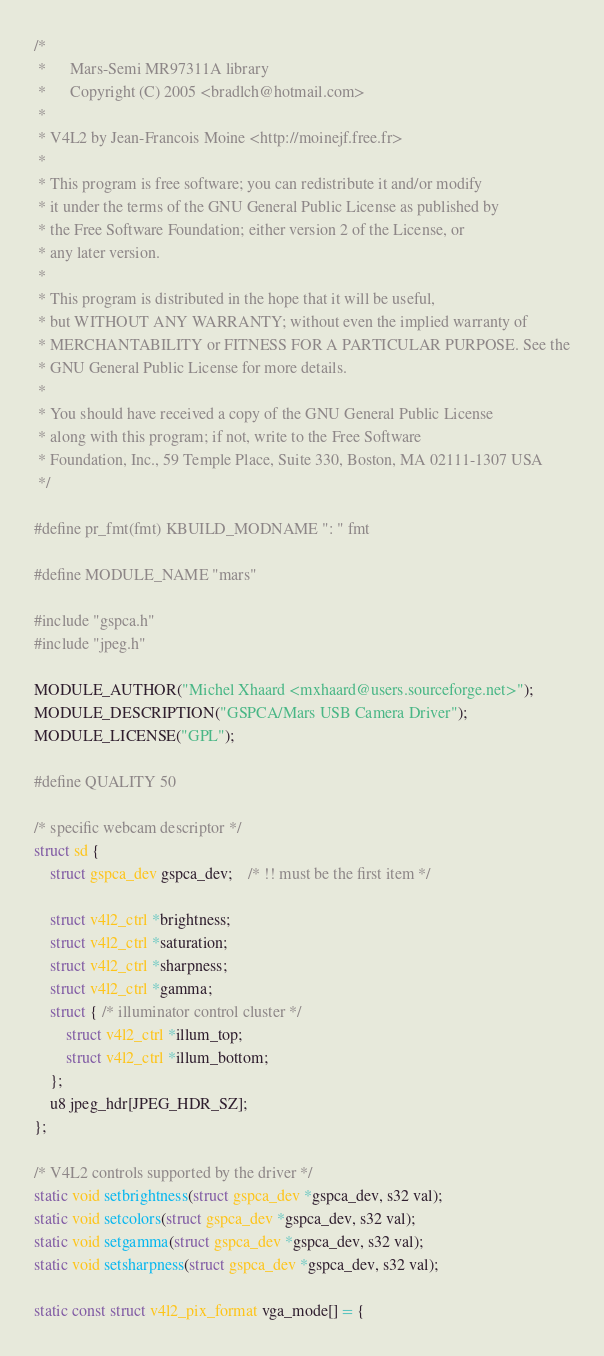Convert code to text. <code><loc_0><loc_0><loc_500><loc_500><_C_>/*
 *		Mars-Semi MR97311A library
 *		Copyright (C) 2005 <bradlch@hotmail.com>
 *
 * V4L2 by Jean-Francois Moine <http://moinejf.free.fr>
 *
 * This program is free software; you can redistribute it and/or modify
 * it under the terms of the GNU General Public License as published by
 * the Free Software Foundation; either version 2 of the License, or
 * any later version.
 *
 * This program is distributed in the hope that it will be useful,
 * but WITHOUT ANY WARRANTY; without even the implied warranty of
 * MERCHANTABILITY or FITNESS FOR A PARTICULAR PURPOSE. See the
 * GNU General Public License for more details.
 *
 * You should have received a copy of the GNU General Public License
 * along with this program; if not, write to the Free Software
 * Foundation, Inc., 59 Temple Place, Suite 330, Boston, MA 02111-1307 USA
 */

#define pr_fmt(fmt) KBUILD_MODNAME ": " fmt

#define MODULE_NAME "mars"

#include "gspca.h"
#include "jpeg.h"

MODULE_AUTHOR("Michel Xhaard <mxhaard@users.sourceforge.net>");
MODULE_DESCRIPTION("GSPCA/Mars USB Camera Driver");
MODULE_LICENSE("GPL");

#define QUALITY 50

/* specific webcam descriptor */
struct sd {
	struct gspca_dev gspca_dev;	/* !! must be the first item */

	struct v4l2_ctrl *brightness;
	struct v4l2_ctrl *saturation;
	struct v4l2_ctrl *sharpness;
	struct v4l2_ctrl *gamma;
	struct { /* illuminator control cluster */
		struct v4l2_ctrl *illum_top;
		struct v4l2_ctrl *illum_bottom;
	};
	u8 jpeg_hdr[JPEG_HDR_SZ];
};

/* V4L2 controls supported by the driver */
static void setbrightness(struct gspca_dev *gspca_dev, s32 val);
static void setcolors(struct gspca_dev *gspca_dev, s32 val);
static void setgamma(struct gspca_dev *gspca_dev, s32 val);
static void setsharpness(struct gspca_dev *gspca_dev, s32 val);

static const struct v4l2_pix_format vga_mode[] = {</code> 